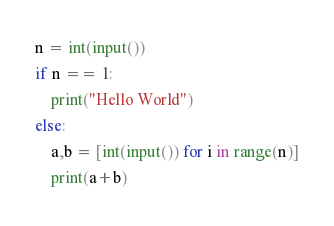Convert code to text. <code><loc_0><loc_0><loc_500><loc_500><_Python_>n = int(input())
if n == 1:
    print("Hello World")
else:
    a,b = [int(input()) for i in range(n)]
    print(a+b)</code> 